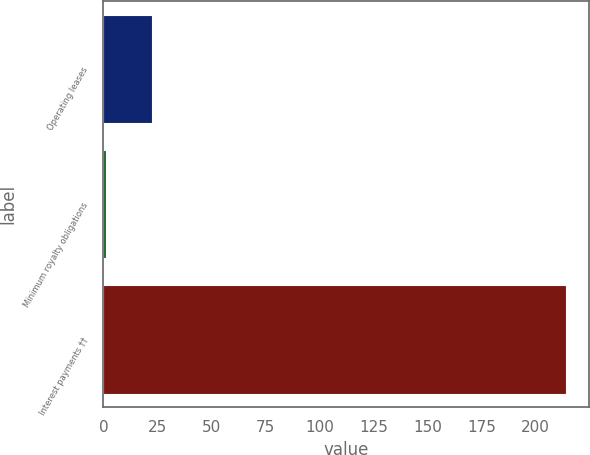<chart> <loc_0><loc_0><loc_500><loc_500><bar_chart><fcel>Operating leases<fcel>Minimum royalty obligations<fcel>Interest payments ††<nl><fcel>22.3<fcel>1<fcel>214<nl></chart> 